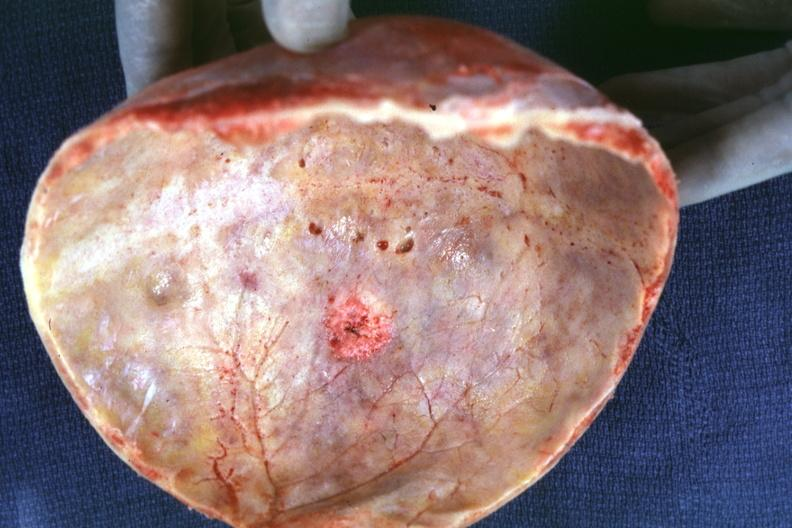how is skull cap with obvious metastatic lesion seen on table prostate primary?
Answer the question using a single word or phrase. Inner 